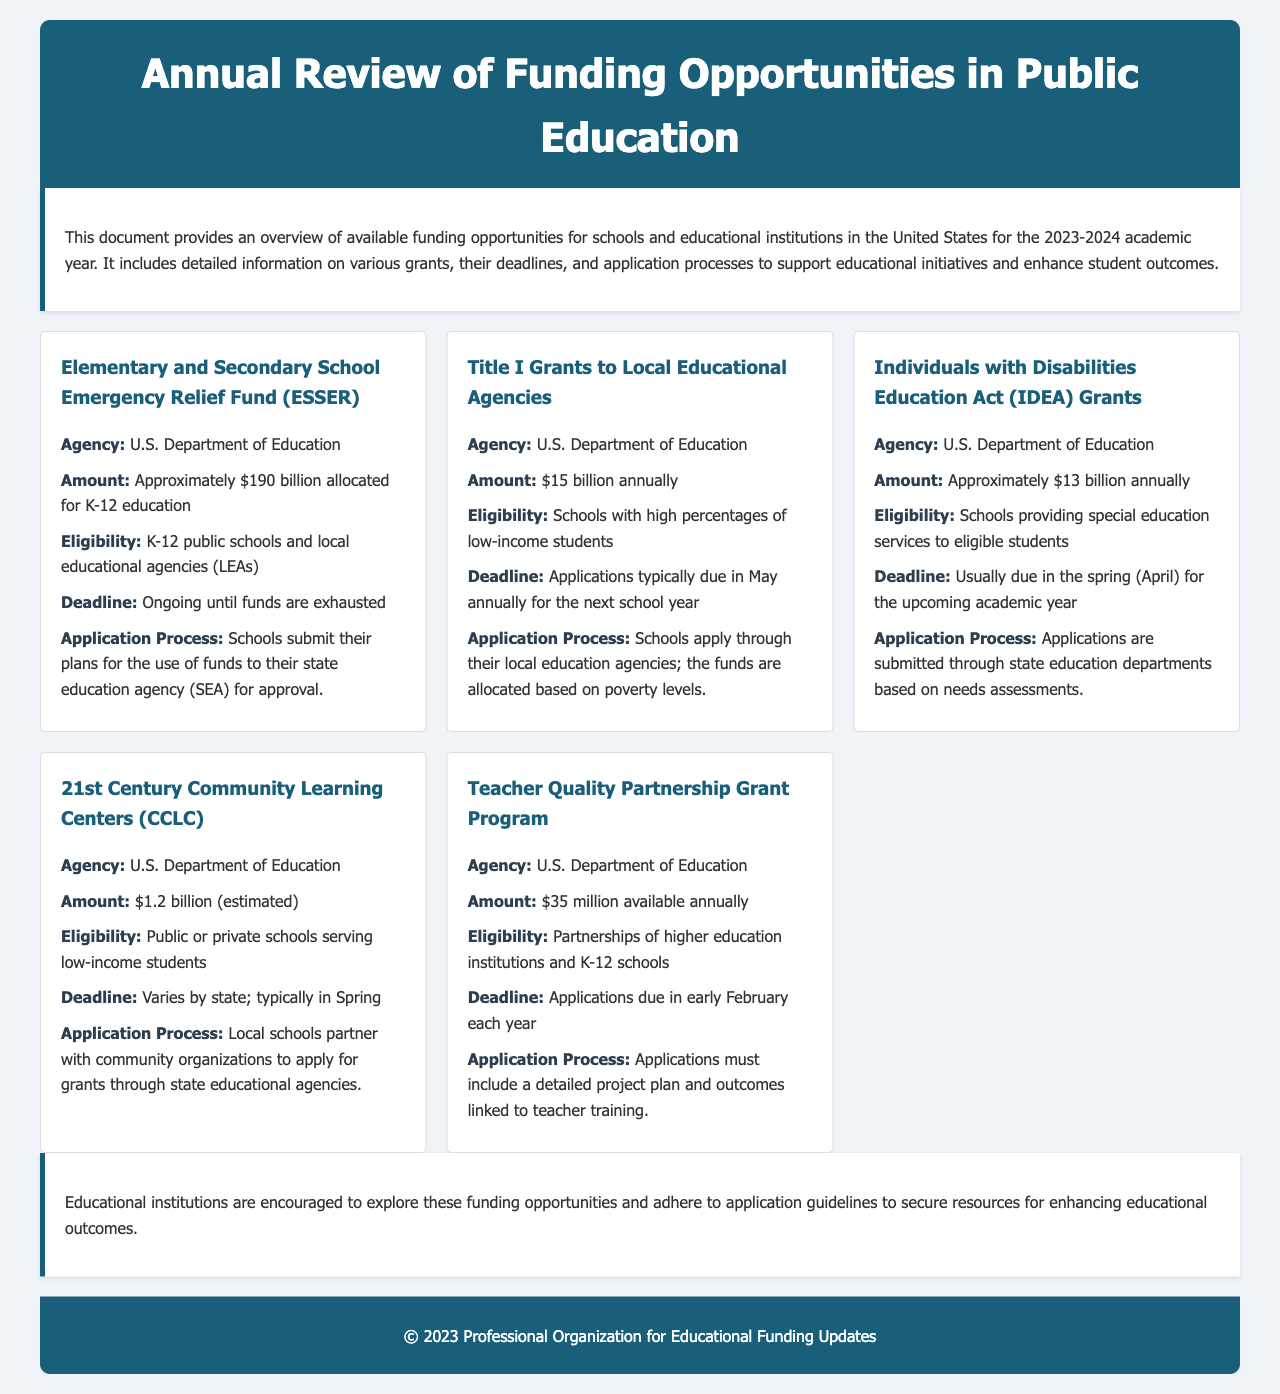What is the amount allocated for the ESSER fund? The ESSER fund has approximately $190 billion allocated for K-12 education as specified in the document.
Answer: Approximately $190 billion Who is eligible for the Title I Grants? The document states that schools with high percentages of low-income students are eligible for Title I Grants.
Answer: Schools with high percentages of low-income students When are applications for IDEA Grants typically due? According to the information provided, applications for IDEA Grants are usually due in April for the upcoming academic year.
Answer: April What is the amount available annually for the Teacher Quality Partnership Grant Program? The document mentions that $35 million is available annually for the Teacher Quality Partnership Grant Program.
Answer: $35 million What is the deadline for 21st Century Community Learning Centers applications? The document indicates that the deadline for applications varies by state, typically occurring in Spring.
Answer: Varies by state; typically in Spring Which agency administers the Elementary and Secondary School Emergency Relief Fund? The U.S. Department of Education administers the ESSER fund as outlined in the document.
Answer: U.S. Department of Education What process must schools follow to apply for the ESSER fund? Schools submit their plans for the use of funds to their state education agency for approval according to the document.
Answer: Submit plans to state education agency Which type of educational institutions are eligible for the 21st Century Community Learning Centers? Public or private schools serving low-income students are eligible as specified in the document.
Answer: Public or private schools serving low-income students What is emphasized in the conclusion of the document? The conclusion encourages educational institutions to explore the funding opportunities and adhere to application guidelines as stated.
Answer: Explore funding opportunities and adhere to application guidelines 